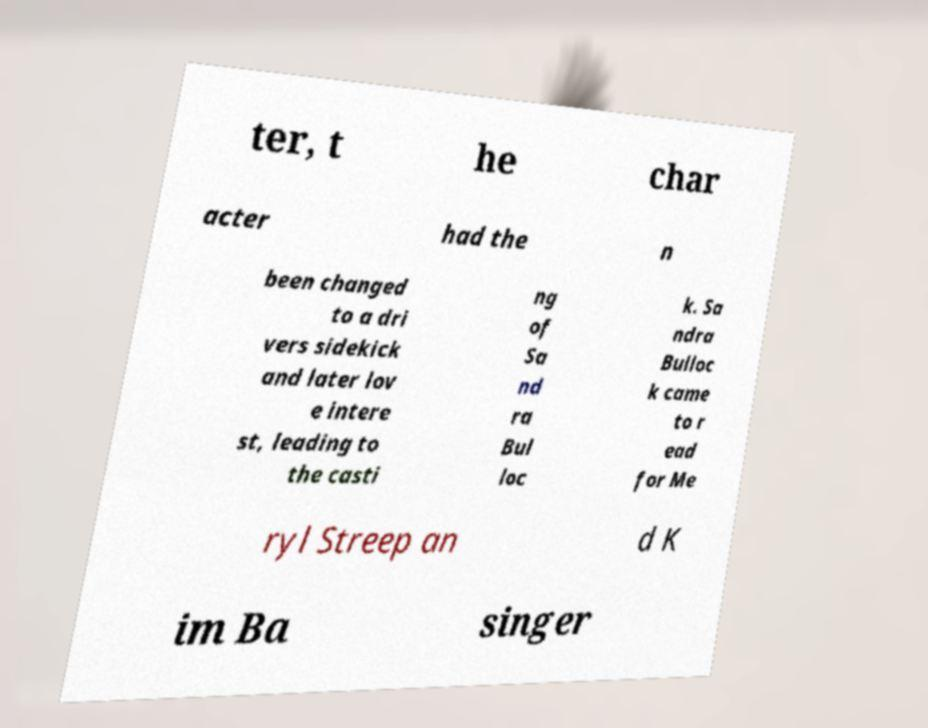For documentation purposes, I need the text within this image transcribed. Could you provide that? ter, t he char acter had the n been changed to a dri vers sidekick and later lov e intere st, leading to the casti ng of Sa nd ra Bul loc k. Sa ndra Bulloc k came to r ead for Me ryl Streep an d K im Ba singer 